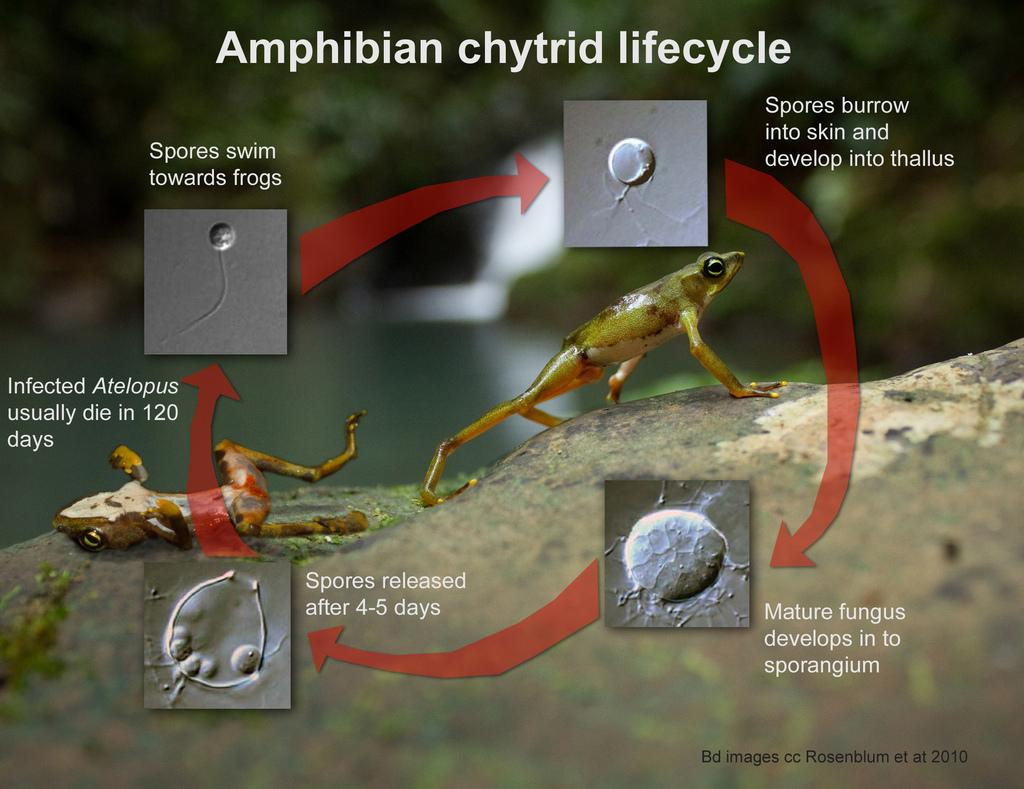What type of diagram is present in the image? There is a cyclic diagram in the image. Can you describe any living organisms in the image? Yes, there are two frogs in the image. What type of lace is being used to decorate the throat of the frog in the image? There is no lace or decoration on the frogs in the image; they are depicted in their natural state. 